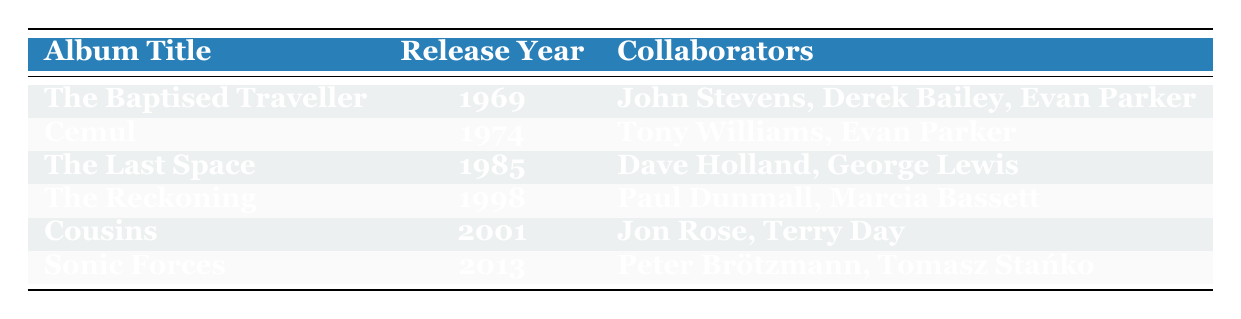What is the release year of "The Baptised Traveller"? The table lists "The Baptised Traveller" under the "Album Title" column and shows "1969" in the corresponding "Release Year" column.
Answer: 1969 Which album was released the latest? By examining the "Release Year" column, the highest value is "2013" for the album "Sonic Forces."
Answer: Sonic Forces How many albums did Tony Oxley release in the 1980s? The albums released in the 1980s are "The Last Space" (1985). There is only one album from that decade listed in the table.
Answer: 1 Was Tony Oxley involved in any albums with Evan Parker? Looking at the collaborators column, "Evan Parker" appears as a collaborator in two albums: "The Baptised Traveller" (1969) and "Cemul" (1974). Thus, the answer is yes.
Answer: Yes Which album has the most collaborators listed? The albums and their collaborators count: "The Baptised Traveller" and "Cemul" have 3 collaborators, while "The Last Space," "The Reckoning," "Cousins," and "Sonic Forces" have 2 collaborators each. Therefore, "The Baptised Traveller" has the most collaborators.
Answer: The Baptised Traveller How many years apart were "Cemul" and "Sonic Forces" released? To find the difference, subtract the release year of "Cemul" (1974) from "Sonic Forces" (2013): 2013 - 1974 = 39 years.
Answer: 39 years Did Tony Oxley collaborate with any drummers? Checking the collaborators, "Tony Williams" is a renowned drummer listed in the album "Cemul." Thus, the answer is yes.
Answer: Yes Which albums were released in the 2000s? Looking at the "Release Year" column, the album "Cousins" is the only one listed from that decade (2001).
Answer: Cousins What is the total number of unique collaborators across all albums? The unique collaborators from the table are: John Stevens, Derek Bailey, Evan Parker, Tony Williams, Dave Holland, George Lewis, Paul Dunmall, Marcia Bassett, Jon Rose, Terry Day, Peter Brötzmann, and Tomasz Stańko. This counts to 12 unique collaborators in total.
Answer: 12 